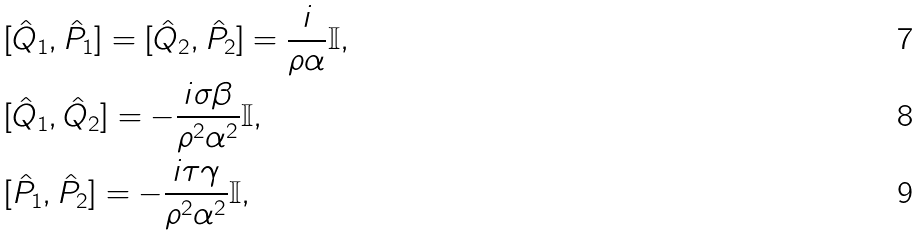<formula> <loc_0><loc_0><loc_500><loc_500>& [ \hat { Q } _ { 1 } , \hat { P } _ { 1 } ] = [ \hat { Q } _ { 2 } , \hat { P } _ { 2 } ] = \frac { i } { \rho \alpha } \mathbb { I } , \\ & [ \hat { Q } _ { 1 } , \hat { Q } _ { 2 } ] = - \frac { i \sigma \beta } { \rho ^ { 2 } \alpha ^ { 2 } } \mathbb { I } , \\ & [ \hat { P } _ { 1 } , \hat { P } _ { 2 } ] = - \frac { i \tau \gamma } { \rho ^ { 2 } \alpha ^ { 2 } } \mathbb { I } ,</formula> 